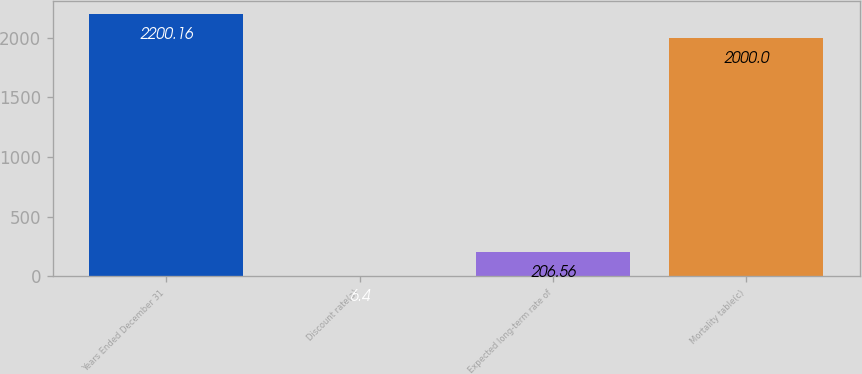Convert chart to OTSL. <chart><loc_0><loc_0><loc_500><loc_500><bar_chart><fcel>Years Ended December 31<fcel>Discount rate(a)<fcel>Expected long-term rate of<fcel>Mortality table(c)<nl><fcel>2200.16<fcel>6.4<fcel>206.56<fcel>2000<nl></chart> 